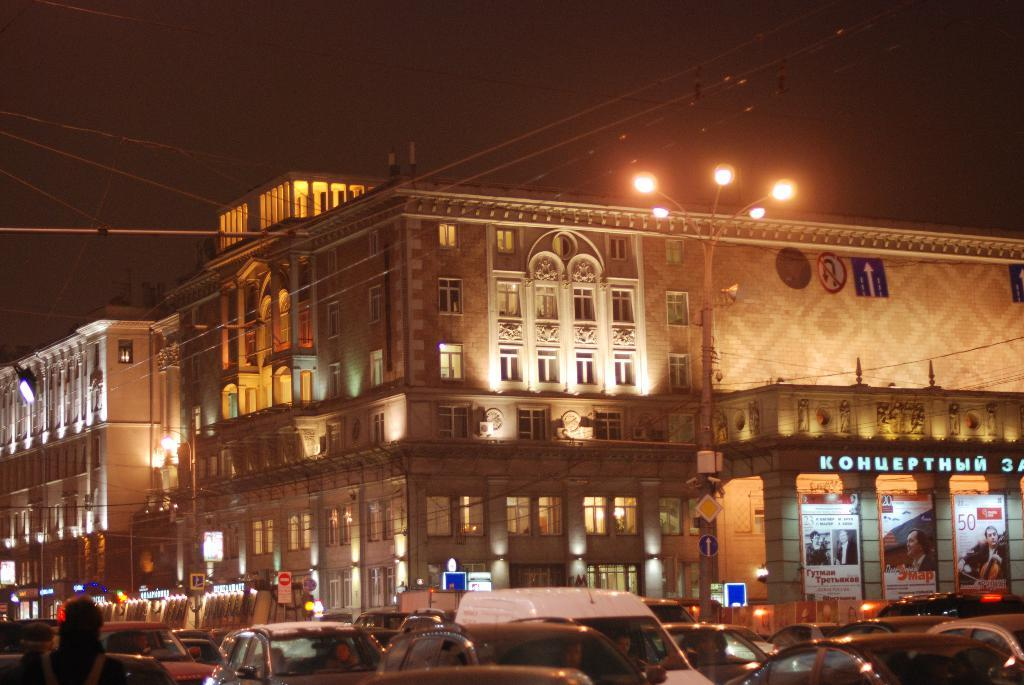What is happening on the road in the image? There are vehicles on the road in the image. What objects can be seen in the image besides the vehicles? There are poles, lights, boards, and cables in the image. How many buildings are visible in the image? There are two buildings in the image. What is the color of the background in the image? The background of the image is dark. What type of food is being served by the jellyfish in the image? There are no jellyfish present in the image. How does the image make you feel? The image itself does not evoke a specific feeling, as it is a static representation of a scene. 